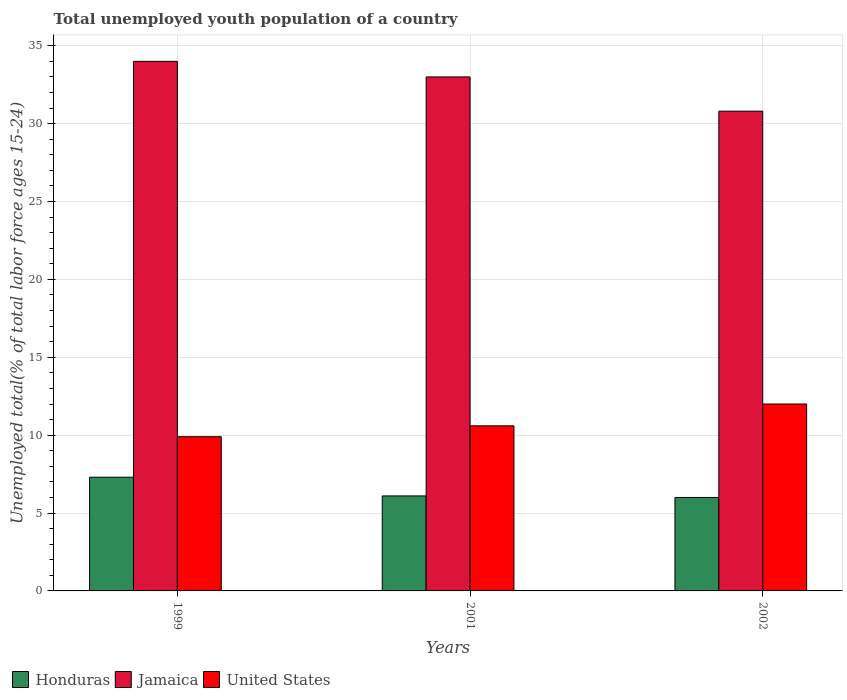How many different coloured bars are there?
Your response must be concise. 3. How many bars are there on the 1st tick from the left?
Make the answer very short. 3. In how many cases, is the number of bars for a given year not equal to the number of legend labels?
Make the answer very short. 0. What is the percentage of total unemployed youth population of a country in Honduras in 2001?
Offer a terse response. 6.1. Across all years, what is the maximum percentage of total unemployed youth population of a country in United States?
Keep it short and to the point. 12. In which year was the percentage of total unemployed youth population of a country in Honduras maximum?
Give a very brief answer. 1999. What is the total percentage of total unemployed youth population of a country in Jamaica in the graph?
Provide a short and direct response. 97.8. What is the difference between the percentage of total unemployed youth population of a country in United States in 1999 and that in 2001?
Offer a terse response. -0.7. What is the difference between the percentage of total unemployed youth population of a country in Honduras in 2001 and the percentage of total unemployed youth population of a country in United States in 1999?
Provide a succinct answer. -3.8. What is the average percentage of total unemployed youth population of a country in United States per year?
Make the answer very short. 10.83. In the year 1999, what is the difference between the percentage of total unemployed youth population of a country in Jamaica and percentage of total unemployed youth population of a country in United States?
Make the answer very short. 24.1. What is the ratio of the percentage of total unemployed youth population of a country in Honduras in 1999 to that in 2001?
Your answer should be very brief. 1.2. Is the percentage of total unemployed youth population of a country in Honduras in 1999 less than that in 2002?
Your answer should be very brief. No. What is the difference between the highest and the second highest percentage of total unemployed youth population of a country in Honduras?
Offer a very short reply. 1.2. What is the difference between the highest and the lowest percentage of total unemployed youth population of a country in Jamaica?
Your response must be concise. 3.2. Is the sum of the percentage of total unemployed youth population of a country in Jamaica in 2001 and 2002 greater than the maximum percentage of total unemployed youth population of a country in United States across all years?
Your response must be concise. Yes. What does the 1st bar from the left in 2002 represents?
Keep it short and to the point. Honduras. What does the 2nd bar from the right in 2002 represents?
Offer a very short reply. Jamaica. Is it the case that in every year, the sum of the percentage of total unemployed youth population of a country in United States and percentage of total unemployed youth population of a country in Honduras is greater than the percentage of total unemployed youth population of a country in Jamaica?
Give a very brief answer. No. Are all the bars in the graph horizontal?
Ensure brevity in your answer.  No. How many years are there in the graph?
Ensure brevity in your answer.  3. Are the values on the major ticks of Y-axis written in scientific E-notation?
Offer a terse response. No. Does the graph contain grids?
Offer a terse response. Yes. What is the title of the graph?
Your answer should be very brief. Total unemployed youth population of a country. What is the label or title of the X-axis?
Offer a terse response. Years. What is the label or title of the Y-axis?
Make the answer very short. Unemployed total(% of total labor force ages 15-24). What is the Unemployed total(% of total labor force ages 15-24) of Honduras in 1999?
Keep it short and to the point. 7.3. What is the Unemployed total(% of total labor force ages 15-24) of United States in 1999?
Your answer should be compact. 9.9. What is the Unemployed total(% of total labor force ages 15-24) in Honduras in 2001?
Your answer should be very brief. 6.1. What is the Unemployed total(% of total labor force ages 15-24) of United States in 2001?
Give a very brief answer. 10.6. What is the Unemployed total(% of total labor force ages 15-24) of Jamaica in 2002?
Your answer should be very brief. 30.8. What is the Unemployed total(% of total labor force ages 15-24) in United States in 2002?
Keep it short and to the point. 12. Across all years, what is the maximum Unemployed total(% of total labor force ages 15-24) of Honduras?
Your response must be concise. 7.3. Across all years, what is the minimum Unemployed total(% of total labor force ages 15-24) in Honduras?
Provide a succinct answer. 6. Across all years, what is the minimum Unemployed total(% of total labor force ages 15-24) in Jamaica?
Make the answer very short. 30.8. Across all years, what is the minimum Unemployed total(% of total labor force ages 15-24) in United States?
Provide a short and direct response. 9.9. What is the total Unemployed total(% of total labor force ages 15-24) of Jamaica in the graph?
Your answer should be compact. 97.8. What is the total Unemployed total(% of total labor force ages 15-24) in United States in the graph?
Keep it short and to the point. 32.5. What is the difference between the Unemployed total(% of total labor force ages 15-24) of Honduras in 1999 and that in 2001?
Your answer should be very brief. 1.2. What is the difference between the Unemployed total(% of total labor force ages 15-24) in Jamaica in 1999 and that in 2001?
Give a very brief answer. 1. What is the difference between the Unemployed total(% of total labor force ages 15-24) in United States in 1999 and that in 2001?
Give a very brief answer. -0.7. What is the difference between the Unemployed total(% of total labor force ages 15-24) in Jamaica in 1999 and that in 2002?
Offer a terse response. 3.2. What is the difference between the Unemployed total(% of total labor force ages 15-24) in United States in 1999 and that in 2002?
Ensure brevity in your answer.  -2.1. What is the difference between the Unemployed total(% of total labor force ages 15-24) in Honduras in 1999 and the Unemployed total(% of total labor force ages 15-24) in Jamaica in 2001?
Keep it short and to the point. -25.7. What is the difference between the Unemployed total(% of total labor force ages 15-24) in Honduras in 1999 and the Unemployed total(% of total labor force ages 15-24) in United States in 2001?
Ensure brevity in your answer.  -3.3. What is the difference between the Unemployed total(% of total labor force ages 15-24) in Jamaica in 1999 and the Unemployed total(% of total labor force ages 15-24) in United States in 2001?
Give a very brief answer. 23.4. What is the difference between the Unemployed total(% of total labor force ages 15-24) of Honduras in 1999 and the Unemployed total(% of total labor force ages 15-24) of Jamaica in 2002?
Make the answer very short. -23.5. What is the difference between the Unemployed total(% of total labor force ages 15-24) of Honduras in 1999 and the Unemployed total(% of total labor force ages 15-24) of United States in 2002?
Offer a very short reply. -4.7. What is the difference between the Unemployed total(% of total labor force ages 15-24) of Honduras in 2001 and the Unemployed total(% of total labor force ages 15-24) of Jamaica in 2002?
Your answer should be compact. -24.7. What is the difference between the Unemployed total(% of total labor force ages 15-24) in Honduras in 2001 and the Unemployed total(% of total labor force ages 15-24) in United States in 2002?
Your answer should be very brief. -5.9. What is the average Unemployed total(% of total labor force ages 15-24) in Honduras per year?
Make the answer very short. 6.47. What is the average Unemployed total(% of total labor force ages 15-24) in Jamaica per year?
Ensure brevity in your answer.  32.6. What is the average Unemployed total(% of total labor force ages 15-24) of United States per year?
Your answer should be compact. 10.83. In the year 1999, what is the difference between the Unemployed total(% of total labor force ages 15-24) of Honduras and Unemployed total(% of total labor force ages 15-24) of Jamaica?
Offer a terse response. -26.7. In the year 1999, what is the difference between the Unemployed total(% of total labor force ages 15-24) of Jamaica and Unemployed total(% of total labor force ages 15-24) of United States?
Provide a short and direct response. 24.1. In the year 2001, what is the difference between the Unemployed total(% of total labor force ages 15-24) in Honduras and Unemployed total(% of total labor force ages 15-24) in Jamaica?
Ensure brevity in your answer.  -26.9. In the year 2001, what is the difference between the Unemployed total(% of total labor force ages 15-24) of Jamaica and Unemployed total(% of total labor force ages 15-24) of United States?
Give a very brief answer. 22.4. In the year 2002, what is the difference between the Unemployed total(% of total labor force ages 15-24) of Honduras and Unemployed total(% of total labor force ages 15-24) of Jamaica?
Offer a very short reply. -24.8. In the year 2002, what is the difference between the Unemployed total(% of total labor force ages 15-24) in Honduras and Unemployed total(% of total labor force ages 15-24) in United States?
Ensure brevity in your answer.  -6. What is the ratio of the Unemployed total(% of total labor force ages 15-24) of Honduras in 1999 to that in 2001?
Your answer should be very brief. 1.2. What is the ratio of the Unemployed total(% of total labor force ages 15-24) in Jamaica in 1999 to that in 2001?
Provide a succinct answer. 1.03. What is the ratio of the Unemployed total(% of total labor force ages 15-24) in United States in 1999 to that in 2001?
Your response must be concise. 0.93. What is the ratio of the Unemployed total(% of total labor force ages 15-24) of Honduras in 1999 to that in 2002?
Ensure brevity in your answer.  1.22. What is the ratio of the Unemployed total(% of total labor force ages 15-24) of Jamaica in 1999 to that in 2002?
Your response must be concise. 1.1. What is the ratio of the Unemployed total(% of total labor force ages 15-24) of United States in 1999 to that in 2002?
Offer a very short reply. 0.82. What is the ratio of the Unemployed total(% of total labor force ages 15-24) in Honduras in 2001 to that in 2002?
Keep it short and to the point. 1.02. What is the ratio of the Unemployed total(% of total labor force ages 15-24) in Jamaica in 2001 to that in 2002?
Your answer should be compact. 1.07. What is the ratio of the Unemployed total(% of total labor force ages 15-24) of United States in 2001 to that in 2002?
Offer a terse response. 0.88. What is the difference between the highest and the second highest Unemployed total(% of total labor force ages 15-24) of Honduras?
Offer a terse response. 1.2. What is the difference between the highest and the second highest Unemployed total(% of total labor force ages 15-24) of Jamaica?
Provide a short and direct response. 1. What is the difference between the highest and the second highest Unemployed total(% of total labor force ages 15-24) of United States?
Your response must be concise. 1.4. What is the difference between the highest and the lowest Unemployed total(% of total labor force ages 15-24) of Honduras?
Offer a terse response. 1.3. What is the difference between the highest and the lowest Unemployed total(% of total labor force ages 15-24) in United States?
Provide a succinct answer. 2.1. 